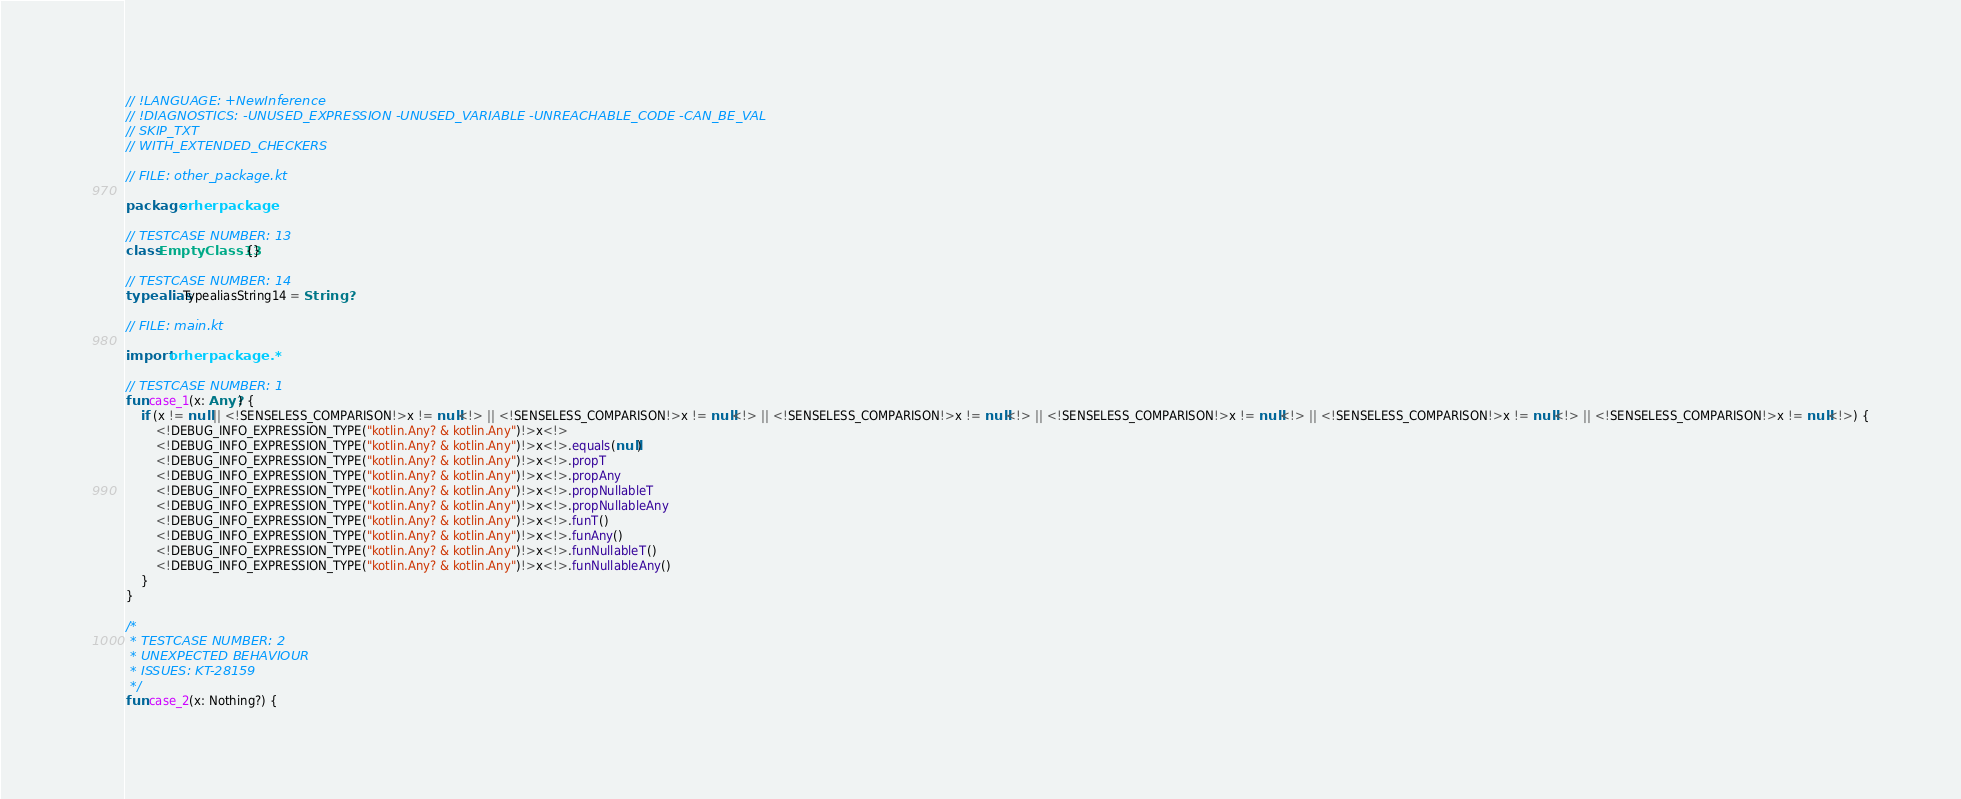<code> <loc_0><loc_0><loc_500><loc_500><_Kotlin_>// !LANGUAGE: +NewInference
// !DIAGNOSTICS: -UNUSED_EXPRESSION -UNUSED_VARIABLE -UNREACHABLE_CODE -CAN_BE_VAL
// SKIP_TXT
// WITH_EXTENDED_CHECKERS

// FILE: other_package.kt

package orherpackage

// TESTCASE NUMBER: 13
class EmptyClass13 {}

// TESTCASE NUMBER: 14
typealias TypealiasString14 = String?

// FILE: main.kt

import orherpackage.*

// TESTCASE NUMBER: 1
fun case_1(x: Any?) {
    if (x != null || <!SENSELESS_COMPARISON!>x != null<!> || <!SENSELESS_COMPARISON!>x != null<!> || <!SENSELESS_COMPARISON!>x != null<!> || <!SENSELESS_COMPARISON!>x != null<!> || <!SENSELESS_COMPARISON!>x != null<!> || <!SENSELESS_COMPARISON!>x != null<!>) {
        <!DEBUG_INFO_EXPRESSION_TYPE("kotlin.Any? & kotlin.Any")!>x<!>
        <!DEBUG_INFO_EXPRESSION_TYPE("kotlin.Any? & kotlin.Any")!>x<!>.equals(null)
        <!DEBUG_INFO_EXPRESSION_TYPE("kotlin.Any? & kotlin.Any")!>x<!>.propT
        <!DEBUG_INFO_EXPRESSION_TYPE("kotlin.Any? & kotlin.Any")!>x<!>.propAny
        <!DEBUG_INFO_EXPRESSION_TYPE("kotlin.Any? & kotlin.Any")!>x<!>.propNullableT
        <!DEBUG_INFO_EXPRESSION_TYPE("kotlin.Any? & kotlin.Any")!>x<!>.propNullableAny
        <!DEBUG_INFO_EXPRESSION_TYPE("kotlin.Any? & kotlin.Any")!>x<!>.funT()
        <!DEBUG_INFO_EXPRESSION_TYPE("kotlin.Any? & kotlin.Any")!>x<!>.funAny()
        <!DEBUG_INFO_EXPRESSION_TYPE("kotlin.Any? & kotlin.Any")!>x<!>.funNullableT()
        <!DEBUG_INFO_EXPRESSION_TYPE("kotlin.Any? & kotlin.Any")!>x<!>.funNullableAny()
    }
}

/*
 * TESTCASE NUMBER: 2
 * UNEXPECTED BEHAVIOUR
 * ISSUES: KT-28159
 */
fun case_2(x: Nothing?) {</code> 